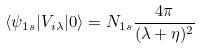<formula> <loc_0><loc_0><loc_500><loc_500>\langle \psi _ { 1 s } | V _ { i \lambda } | 0 \rangle = N _ { 1 s } \frac { 4 \pi } { ( \lambda + \eta ) ^ { 2 } }</formula> 